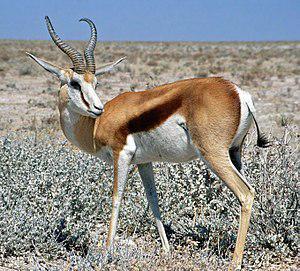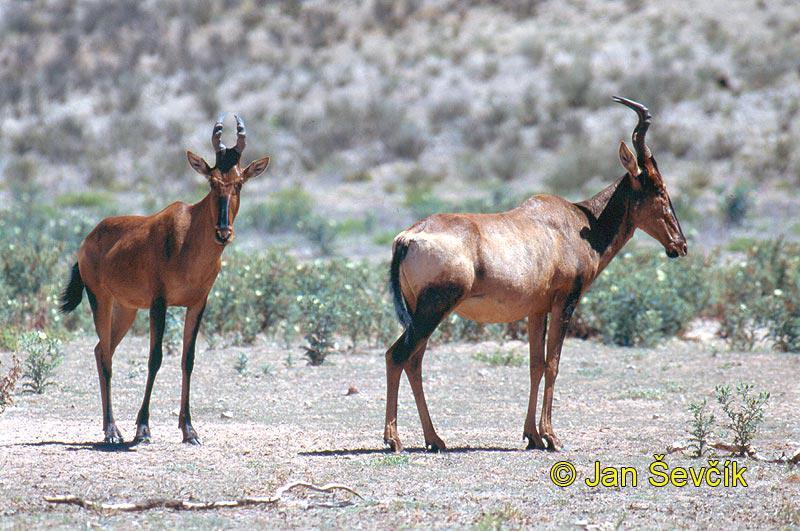The first image is the image on the left, the second image is the image on the right. Evaluate the accuracy of this statement regarding the images: "there are 3 antelope in the image pair". Is it true? Answer yes or no. Yes. 